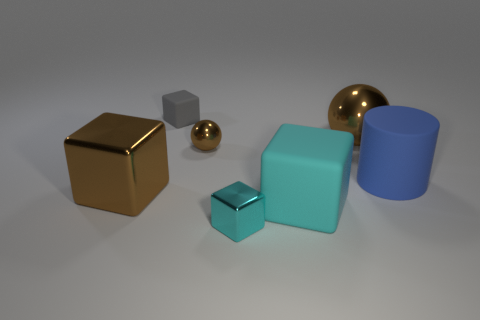How many brown balls must be subtracted to get 1 brown balls? 1 Add 1 cyan blocks. How many objects exist? 8 Subtract all balls. How many objects are left? 5 Subtract 0 green spheres. How many objects are left? 7 Subtract all tiny cyan blocks. Subtract all big metallic cylinders. How many objects are left? 6 Add 1 cubes. How many cubes are left? 5 Add 4 large purple balls. How many large purple balls exist? 4 